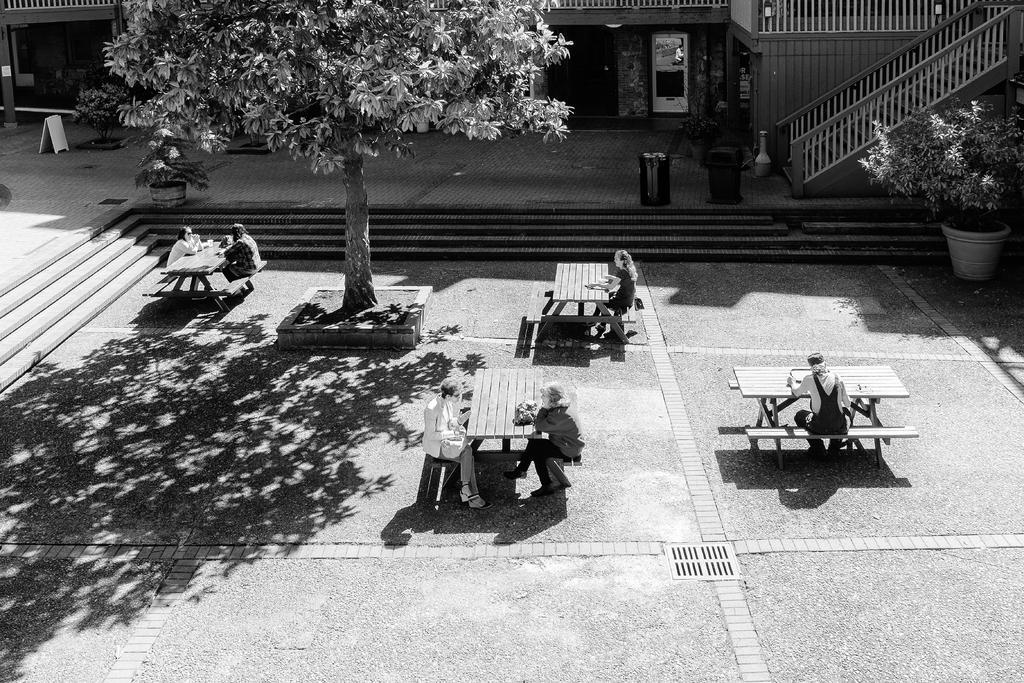In one or two sentences, can you explain what this image depicts? In this image i can see a group of people who are sitting on a chair in front of the table on the floor. Here we have a tree, stairs and a plant. 